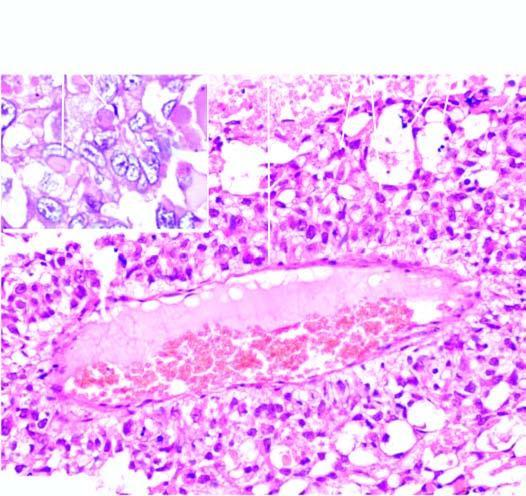does inset show intra - and extracellular hyaline globules?
Answer the question using a single word or phrase. Yes 